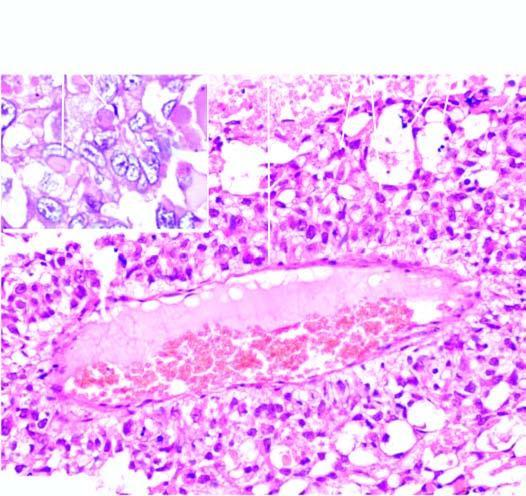does inset show intra - and extracellular hyaline globules?
Answer the question using a single word or phrase. Yes 